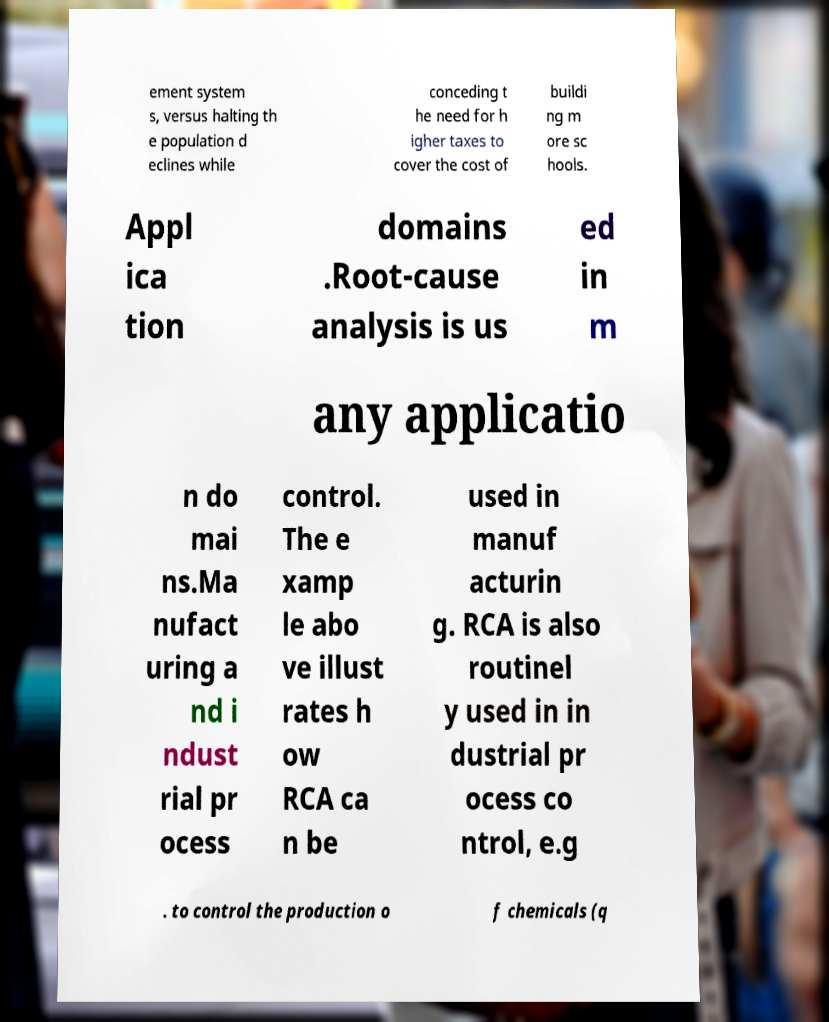Could you assist in decoding the text presented in this image and type it out clearly? ement system s, versus halting th e population d eclines while conceding t he need for h igher taxes to cover the cost of buildi ng m ore sc hools. Appl ica tion domains .Root-cause analysis is us ed in m any applicatio n do mai ns.Ma nufact uring a nd i ndust rial pr ocess control. The e xamp le abo ve illust rates h ow RCA ca n be used in manuf acturin g. RCA is also routinel y used in in dustrial pr ocess co ntrol, e.g . to control the production o f chemicals (q 